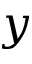<formula> <loc_0><loc_0><loc_500><loc_500>y</formula> 